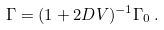Convert formula to latex. <formula><loc_0><loc_0><loc_500><loc_500>\Gamma = ( 1 + 2 D V ) ^ { - 1 } \Gamma _ { 0 } \, .</formula> 